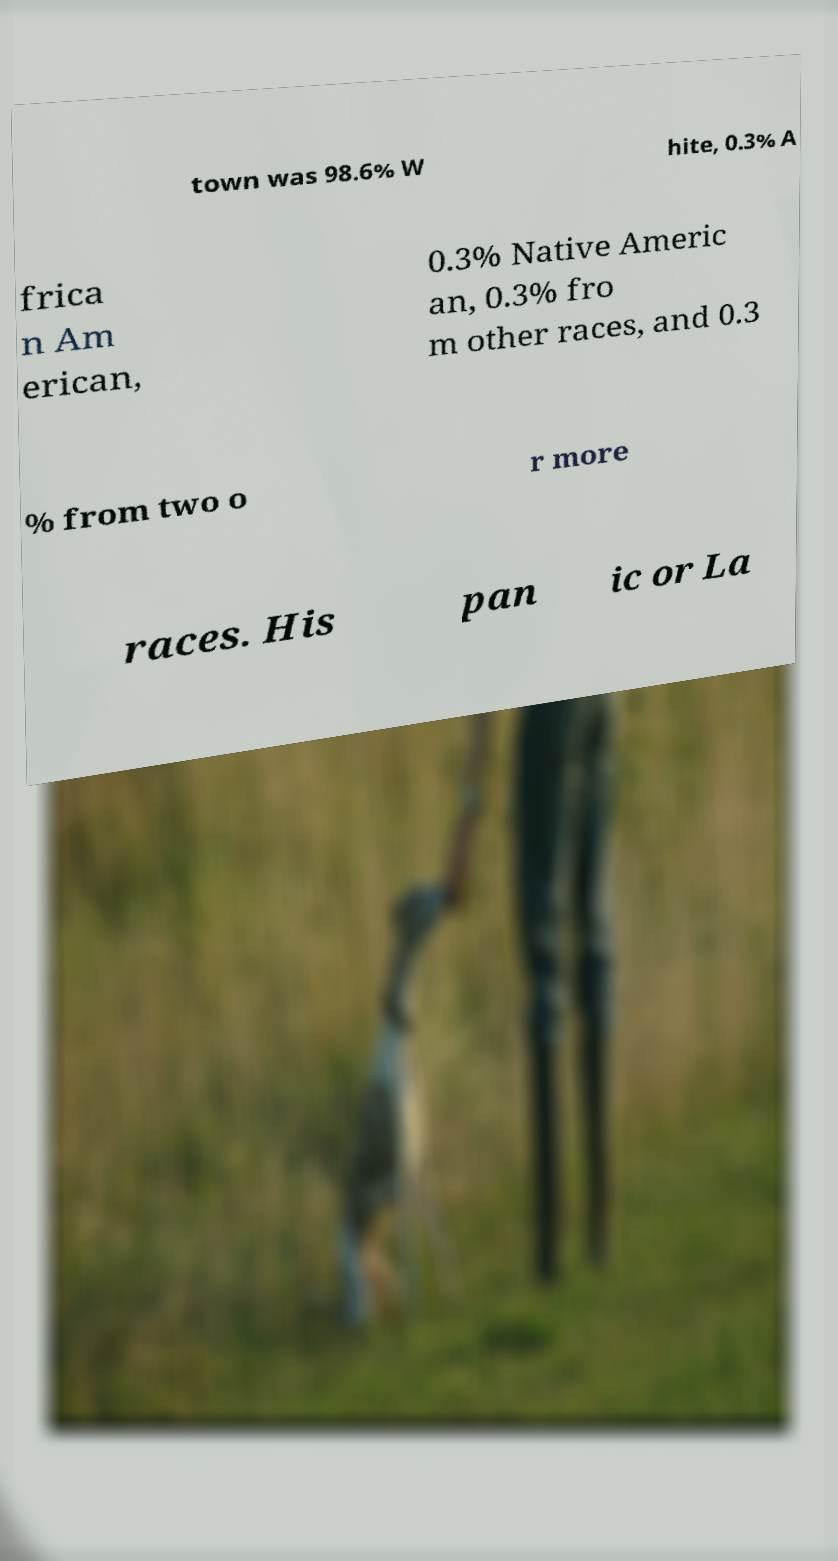I need the written content from this picture converted into text. Can you do that? town was 98.6% W hite, 0.3% A frica n Am erican, 0.3% Native Americ an, 0.3% fro m other races, and 0.3 % from two o r more races. His pan ic or La 